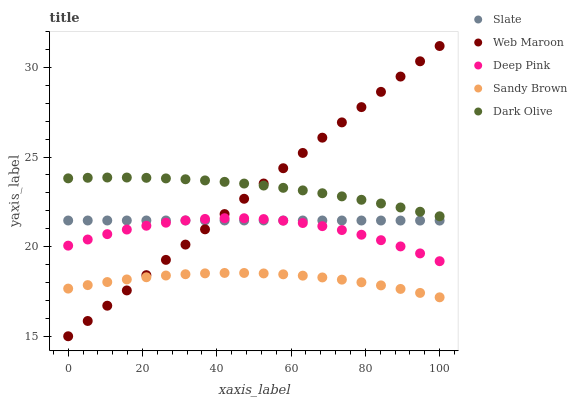Does Sandy Brown have the minimum area under the curve?
Answer yes or no. Yes. Does Dark Olive have the maximum area under the curve?
Answer yes or no. Yes. Does Slate have the minimum area under the curve?
Answer yes or no. No. Does Slate have the maximum area under the curve?
Answer yes or no. No. Is Web Maroon the smoothest?
Answer yes or no. Yes. Is Deep Pink the roughest?
Answer yes or no. Yes. Is Sandy Brown the smoothest?
Answer yes or no. No. Is Sandy Brown the roughest?
Answer yes or no. No. Does Web Maroon have the lowest value?
Answer yes or no. Yes. Does Sandy Brown have the lowest value?
Answer yes or no. No. Does Web Maroon have the highest value?
Answer yes or no. Yes. Does Slate have the highest value?
Answer yes or no. No. Is Deep Pink less than Dark Olive?
Answer yes or no. Yes. Is Dark Olive greater than Slate?
Answer yes or no. Yes. Does Slate intersect Web Maroon?
Answer yes or no. Yes. Is Slate less than Web Maroon?
Answer yes or no. No. Is Slate greater than Web Maroon?
Answer yes or no. No. Does Deep Pink intersect Dark Olive?
Answer yes or no. No. 